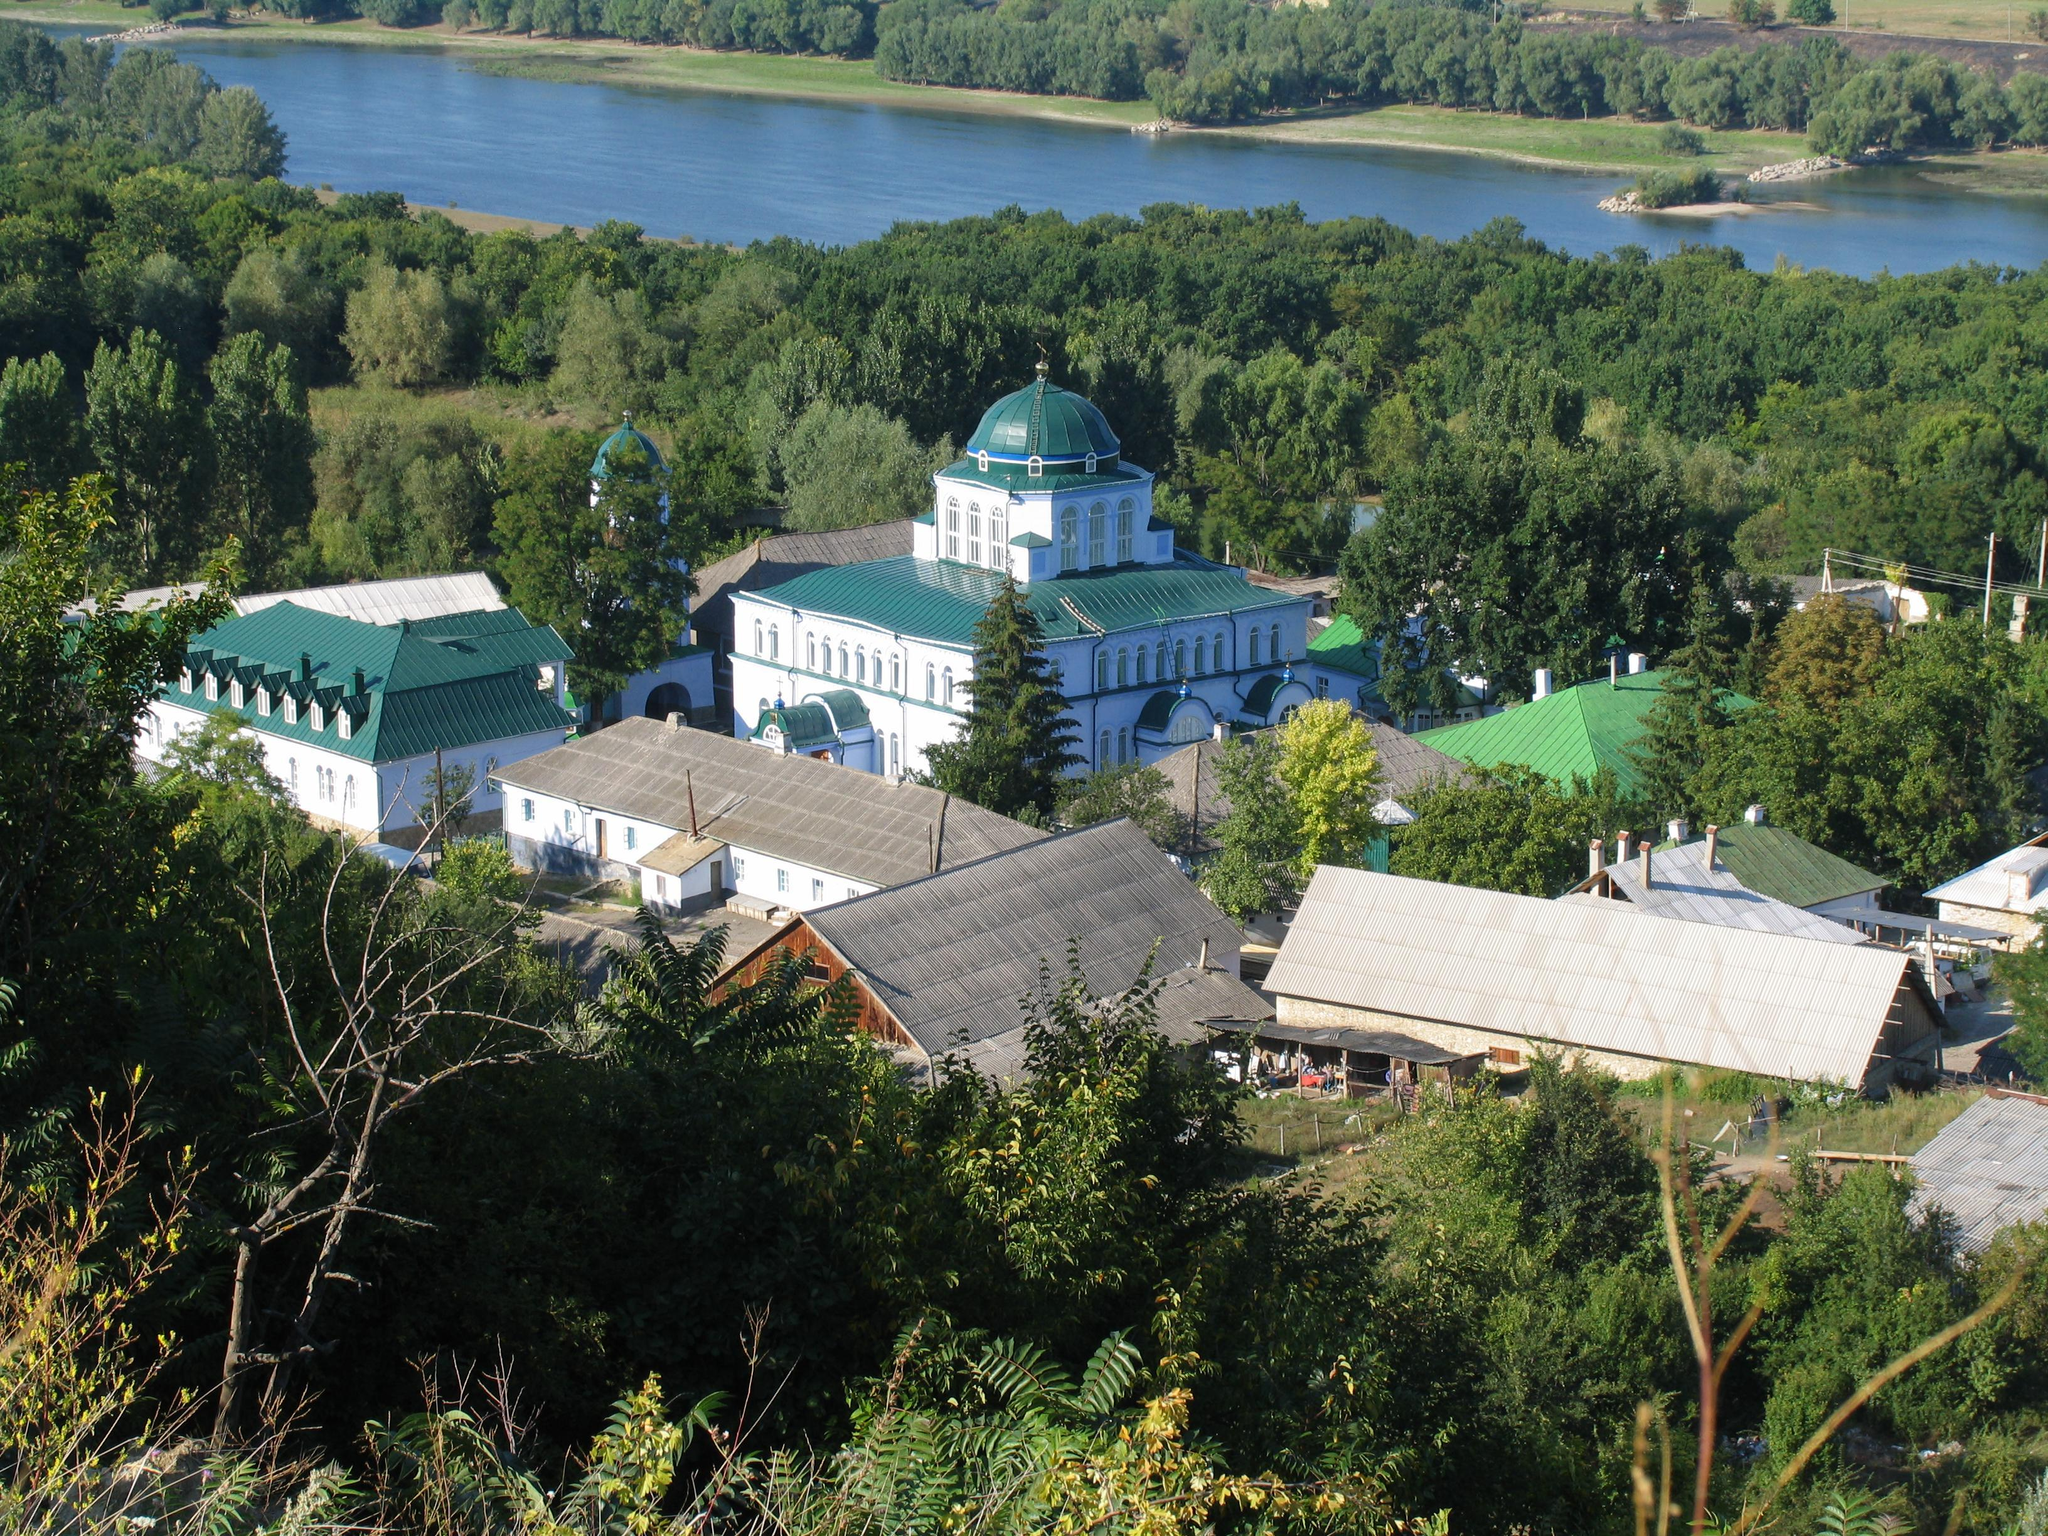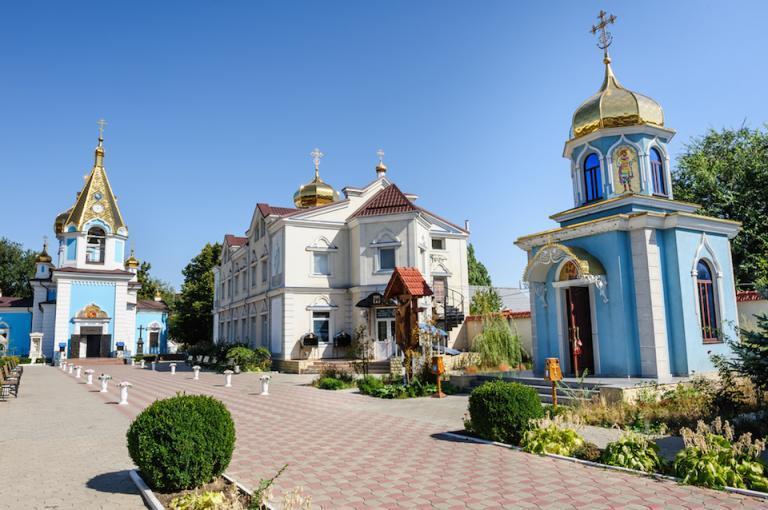The first image is the image on the left, the second image is the image on the right. Evaluate the accuracy of this statement regarding the images: "In one image, a large building is red with white trim and a black decorative rooftop.". Is it true? Answer yes or no. No. The first image is the image on the left, the second image is the image on the right. For the images displayed, is the sentence "One image shows a building topped with multiple dark gray onion-shapes with crosses on top." factually correct? Answer yes or no. No. 